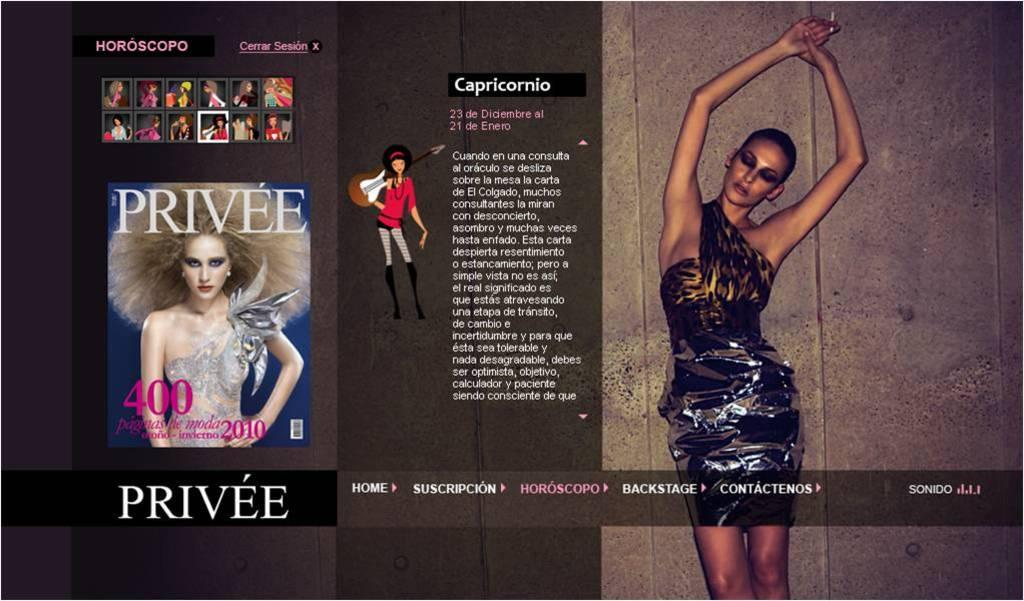What is the main object in the image? There is a poster in the image. What can be seen in the pictures on the poster? The poster contains pictures of people. What else is present on the poster besides the images? There is text on the poster. What type of mountain is visible in the background of the poster? There is no mountain visible in the image, as the focus is on the poster itself. 